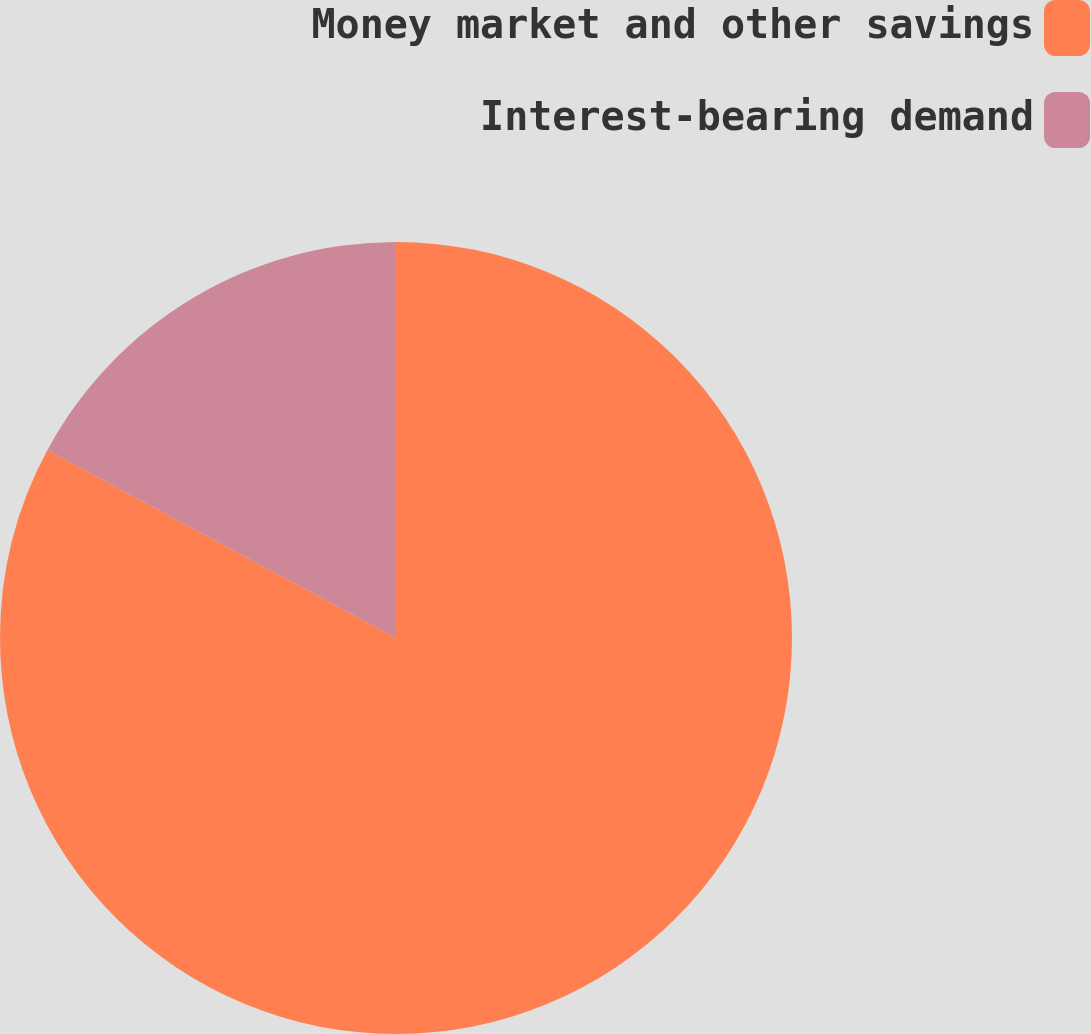<chart> <loc_0><loc_0><loc_500><loc_500><pie_chart><fcel>Money market and other savings<fcel>Interest-bearing demand<nl><fcel>82.87%<fcel>17.13%<nl></chart> 